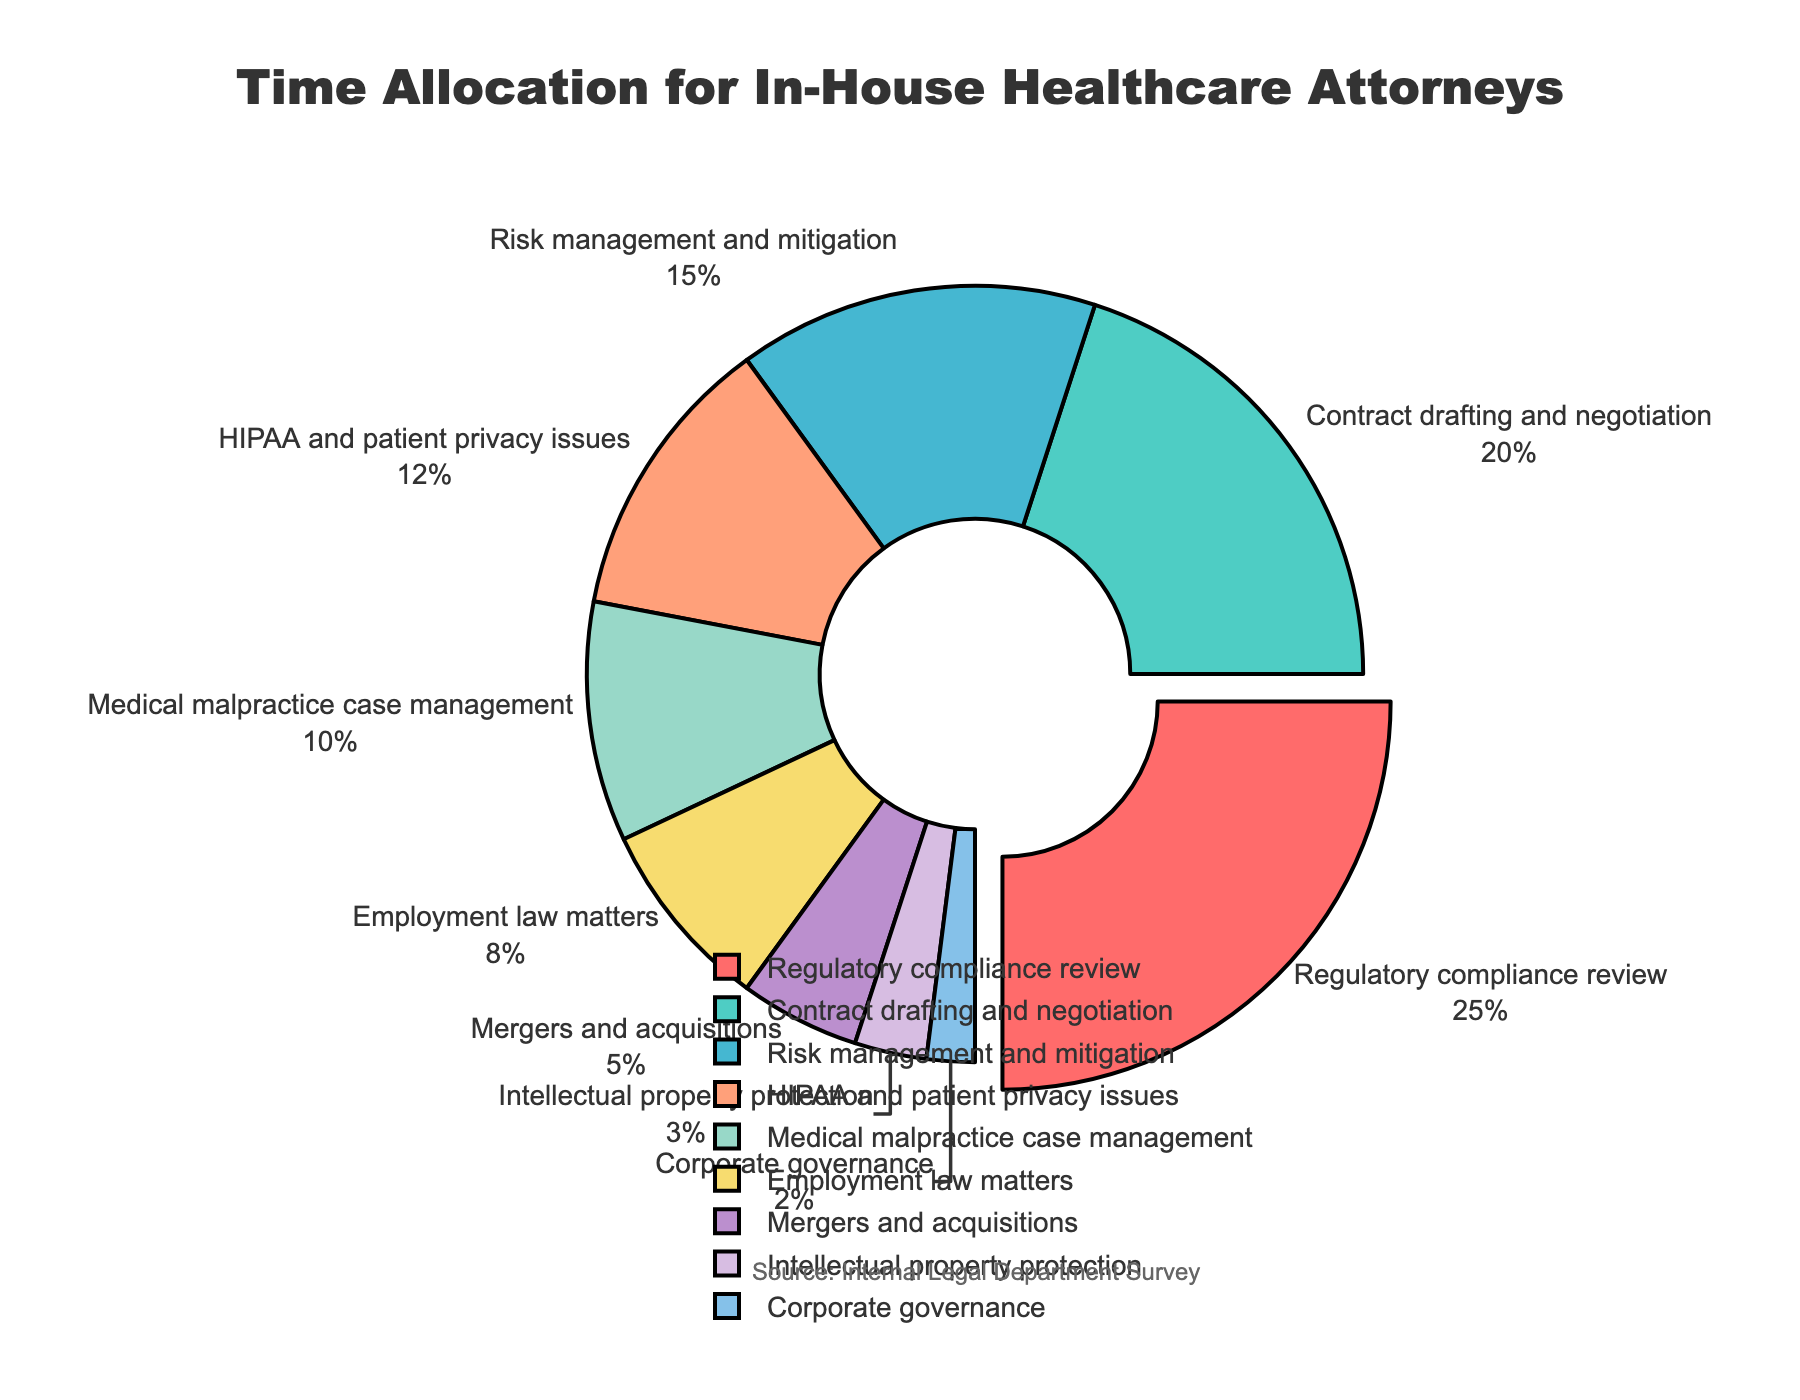What percentage of time is spent on regulatory compliance review? The pie chart shows the proportion of time spent on various legal tasks, with a part specifically representing regulatory compliance review. By looking at the label associated with this segment, we can determine that 25% of the attorneys' time is dedicated to regulatory compliance review.
Answer: 25% How much more time is allocated to contract drafting and negotiation compared to HIPAA and patient privacy issues? By comparing the percentages provided on the pie chart, contract drafting and negotiation takes 20% of the time, while HIPAA and patient privacy issues take 12%. The difference between the two is 20% - 12% = 8%.
Answer: 8% What task occupies the smallest proportion of time for in-house healthcare attorneys? By observing the pie chart, the segment with the smallest percentage is associated with the task of corporate governance, which occupies 2% of the total time.
Answer: Corporate governance What is the combined percentage of time spent on medical malpractice case management and employment law matters? The pie chart shows that 10% of the time is spent on medical malpractice case management and 8% on employment law matters. Adding these two percentages together, we get 10% + 8% = 18%.
Answer: 18% Which legal task's segment is highlighted or "pulled out" in the pie chart, and why might this be done? The segment that is highlighted or "pulled out" in the pie chart is regulatory compliance review. This visual differentiation likely indicates its significance or prominence among the other tasks.
Answer: Regulatory compliance review Does the time spent on risk management and mitigation exceed the time spent on HIPAA and patient privacy issues? According to the pie chart, 15% of the time is allocated to risk management and mitigation, whereas 12% is dedicated to HIPAA and patient privacy issues. Therefore, the time spent on risk management and mitigation indeed exceeds the time spent on HIPAA and patient privacy issues by 15% - 12% = 3%.
Answer: Yes How many tasks altogether account for more than 10% of the total time spent? By analyzing the pie chart, we can see that the tasks which occupy more than 10% of the total time are regulatory compliance review (25%), contract drafting and negotiation (20%), risk management and mitigation (15%), and HIPAA and patient privacy issues (12%). Hence, there are four such tasks.
Answer: 4 What is the difference in the percentage of time between tasks related to intellectual property protection and corporate governance? The pie chart shows that intellectual property protection accounts for 3% of the time while corporate governance accounts for 2%. The difference is 3% - 2% = 1%.
Answer: 1% Between medical malpractice case management and mergers and acquisitions, which task receives less time allocation and by how much? From the pie chart, medical malpractice case management takes 10% of the time, whereas mergers and acquisitions take 5%. Therefore, mergers and acquisitions receive 5% less time allocation compared to medical malpractice case management.
Answer: Mergers and acquisitions, by 5% What visual element in the pie chart indicates the source of the data, and why is this important? The pie chart includes an annotation below the chart that reads "Source: Internal Legal Department Survey". This element provides transparency about the origin of the data, which is important for validating the chart's credibility and ensuring trust in the information presented.
Answer: Source annotation indicating "Internal Legal Department Survey" 